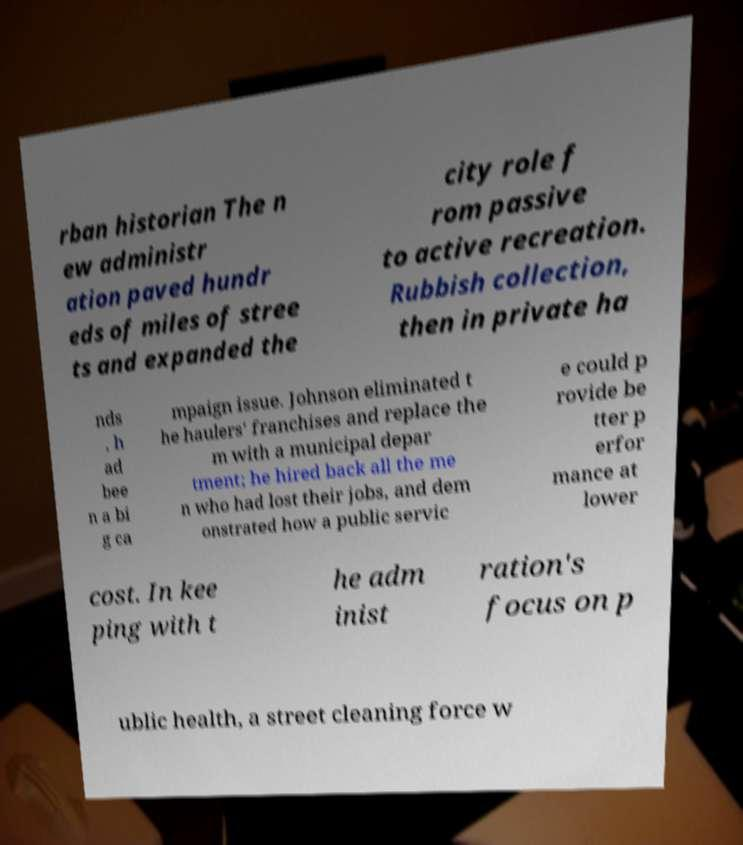Could you extract and type out the text from this image? rban historian The n ew administr ation paved hundr eds of miles of stree ts and expanded the city role f rom passive to active recreation. Rubbish collection, then in private ha nds , h ad bee n a bi g ca mpaign issue. Johnson eliminated t he haulers' franchises and replace the m with a municipal depar tment; he hired back all the me n who had lost their jobs, and dem onstrated how a public servic e could p rovide be tter p erfor mance at lower cost. In kee ping with t he adm inist ration's focus on p ublic health, a street cleaning force w 